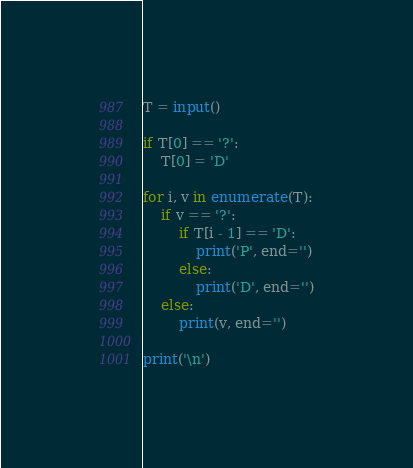Convert code to text. <code><loc_0><loc_0><loc_500><loc_500><_Python_>T = input()

if T[0] == '?':
    T[0] = 'D'

for i, v in enumerate(T):
    if v == '?':
        if T[i - 1] == 'D':
            print('P', end='')
        else:
            print('D', end='')
    else:
        print(v, end='')

print('\n')</code> 